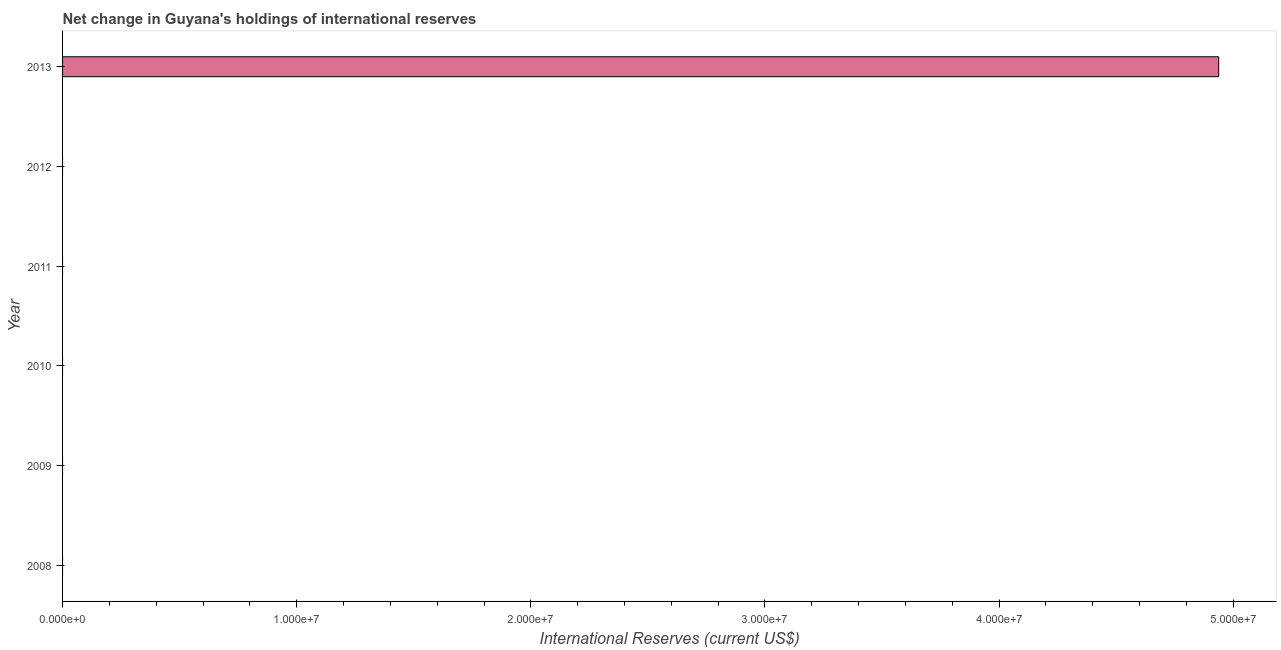Does the graph contain any zero values?
Provide a succinct answer. Yes. What is the title of the graph?
Offer a very short reply. Net change in Guyana's holdings of international reserves. What is the label or title of the X-axis?
Your answer should be compact. International Reserves (current US$). Across all years, what is the maximum reserves and related items?
Your answer should be very brief. 4.94e+07. Across all years, what is the minimum reserves and related items?
Offer a very short reply. 0. What is the sum of the reserves and related items?
Give a very brief answer. 4.94e+07. What is the average reserves and related items per year?
Provide a short and direct response. 8.23e+06. What is the difference between the highest and the lowest reserves and related items?
Give a very brief answer. 4.94e+07. In how many years, is the reserves and related items greater than the average reserves and related items taken over all years?
Offer a terse response. 1. How many bars are there?
Make the answer very short. 1. Are all the bars in the graph horizontal?
Offer a terse response. Yes. What is the difference between two consecutive major ticks on the X-axis?
Offer a terse response. 1.00e+07. What is the International Reserves (current US$) of 2008?
Provide a succinct answer. 0. What is the International Reserves (current US$) of 2012?
Your answer should be compact. 0. What is the International Reserves (current US$) of 2013?
Your answer should be compact. 4.94e+07. 